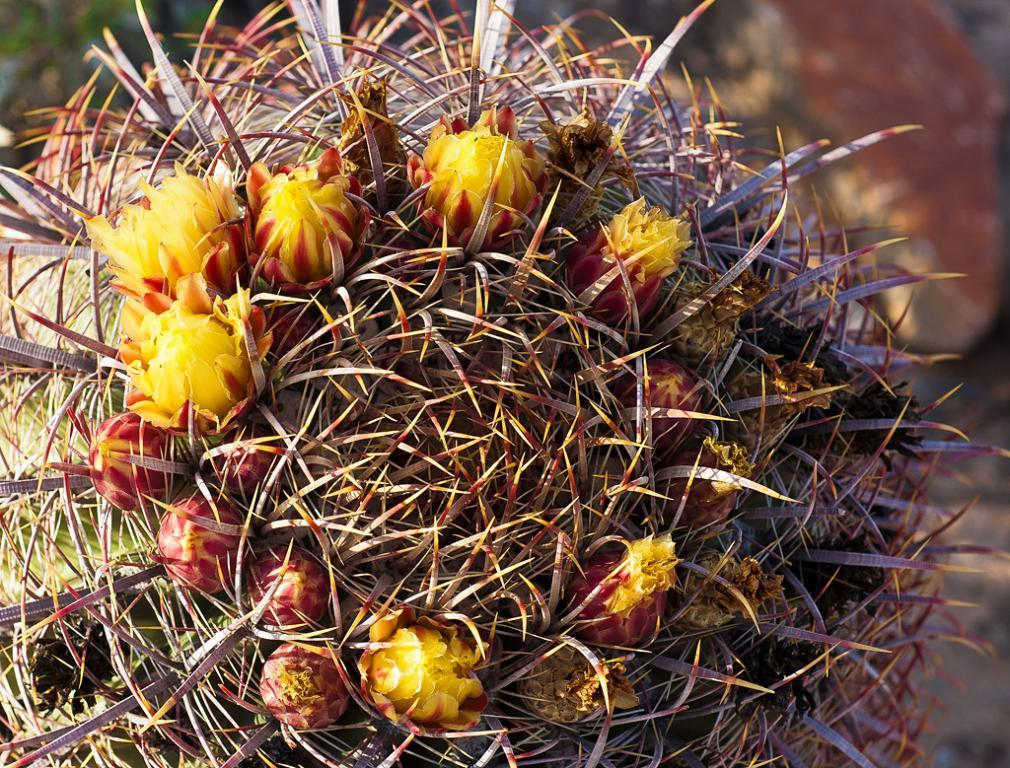Where was the image taken? The image is taken outdoors. What type of plant can be seen in the image? There is a cactus plant in the image. What type of screw can be seen in the image? There is no screw present in the image. What type of waves can be seen in the image? There are no waves present in the image. What type of grape can be seen in the image? There are no grapes present in the image. 